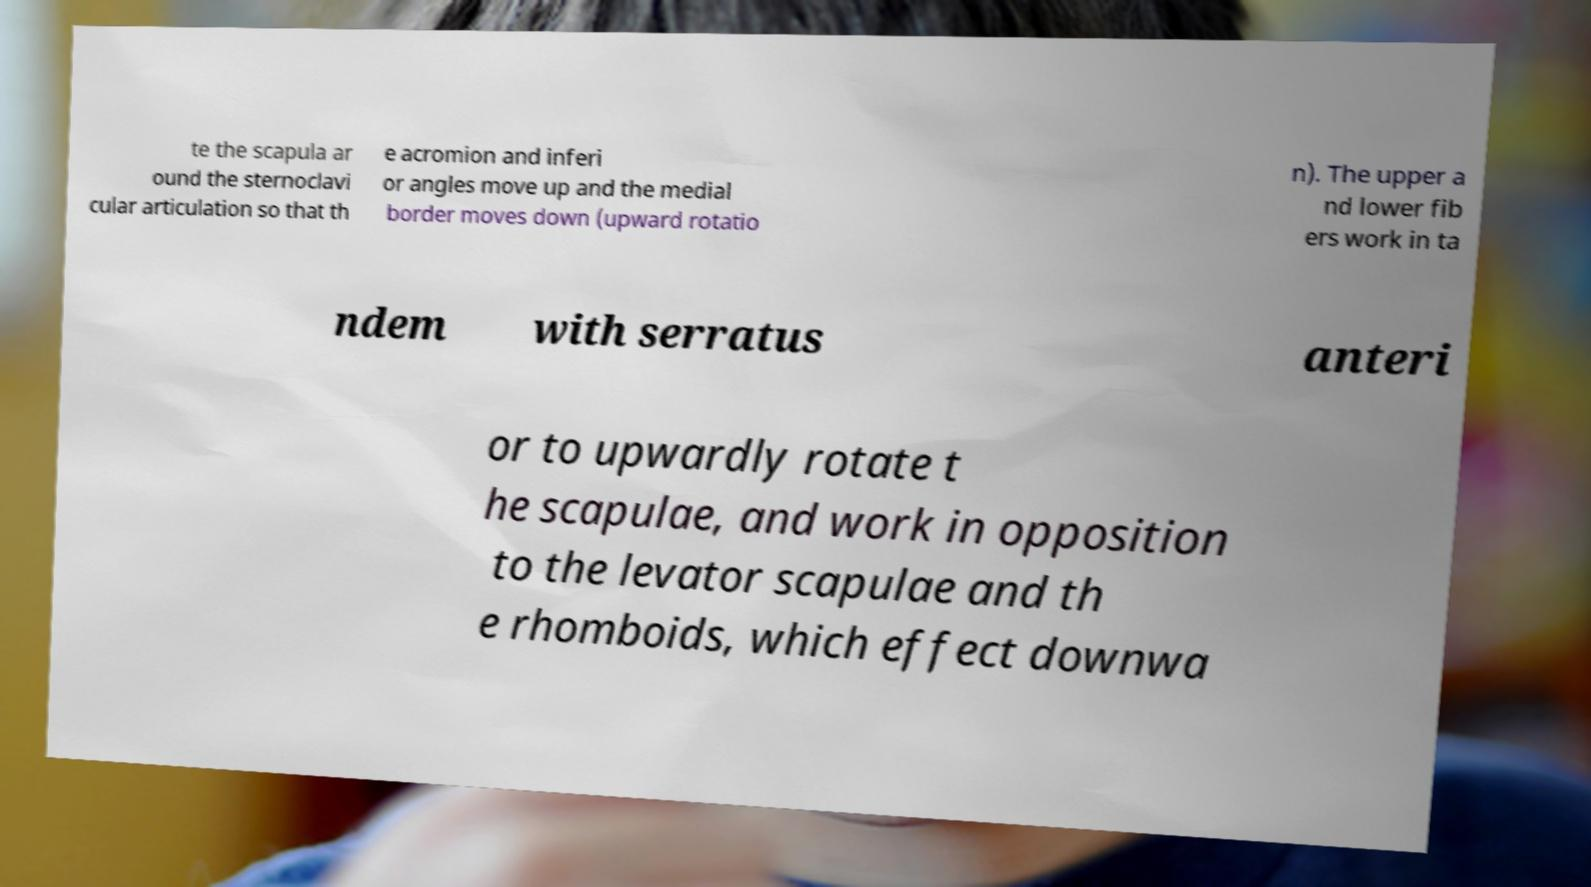What messages or text are displayed in this image? I need them in a readable, typed format. te the scapula ar ound the sternoclavi cular articulation so that th e acromion and inferi or angles move up and the medial border moves down (upward rotatio n). The upper a nd lower fib ers work in ta ndem with serratus anteri or to upwardly rotate t he scapulae, and work in opposition to the levator scapulae and th e rhomboids, which effect downwa 